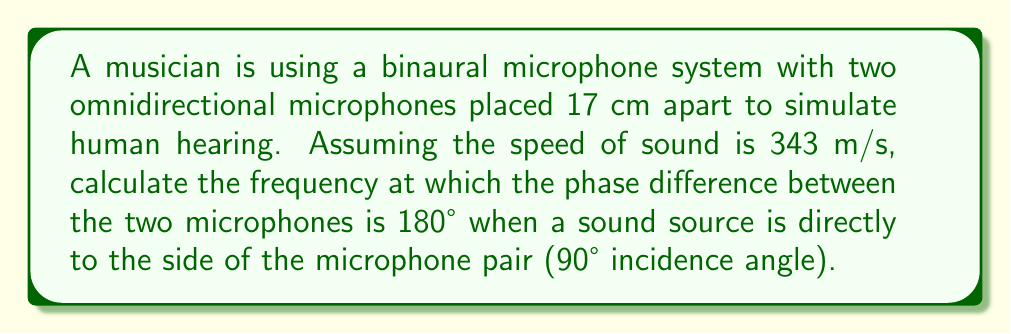Could you help me with this problem? Let's approach this step-by-step:

1) The phase difference (Δφ) between two microphones for a given frequency (f) and path difference (Δd) is given by:

   $$\Delta \phi = \frac{2\pi f \Delta d}{c}$$

   Where c is the speed of sound.

2) For a sound source at 90° incidence, the path difference is equal to the distance between the microphones:

   $$\Delta d = 0.17 \text{ m}$$

3) We want the phase difference to be 180°, which is equivalent to π radians:

   $$\pi = \frac{2\pi f (0.17)}{343}$$

4) Simplify and solve for f:

   $$1 = \frac{2f(0.17)}{343}$$
   $$343 = 2f(0.17)$$
   $$f = \frac{343}{2(0.17)} = \frac{343}{0.34} \approx 1008.82 \text{ Hz}$$

5) Round to the nearest whole number:

   $$f \approx 1009 \text{ Hz}$$

This frequency is known as the "spatial aliasing frequency" for this microphone configuration.
Answer: 1009 Hz 